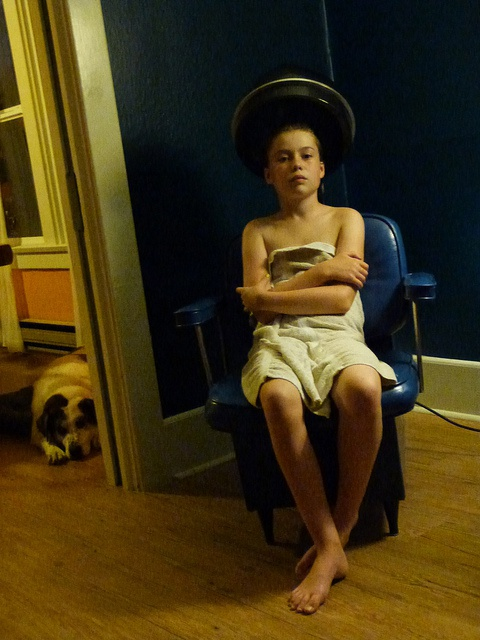Describe the objects in this image and their specific colors. I can see people in black, maroon, and olive tones, chair in black, navy, blue, and olive tones, hair drier in black, darkgreen, olive, and gray tones, and dog in black, olive, and maroon tones in this image. 